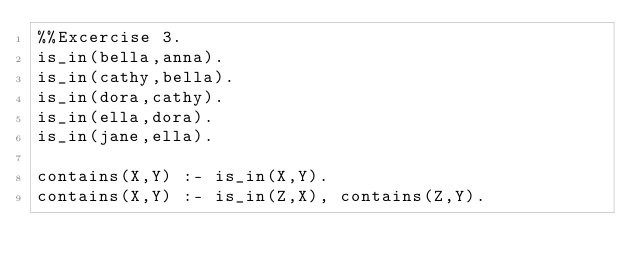<code> <loc_0><loc_0><loc_500><loc_500><_Perl_>%%Excercise 3.
is_in(bella,anna).
is_in(cathy,bella).
is_in(dora,cathy).
is_in(ella,dora).
is_in(jane,ella).

contains(X,Y) :- is_in(X,Y).
contains(X,Y) :- is_in(Z,X), contains(Z,Y).
</code> 